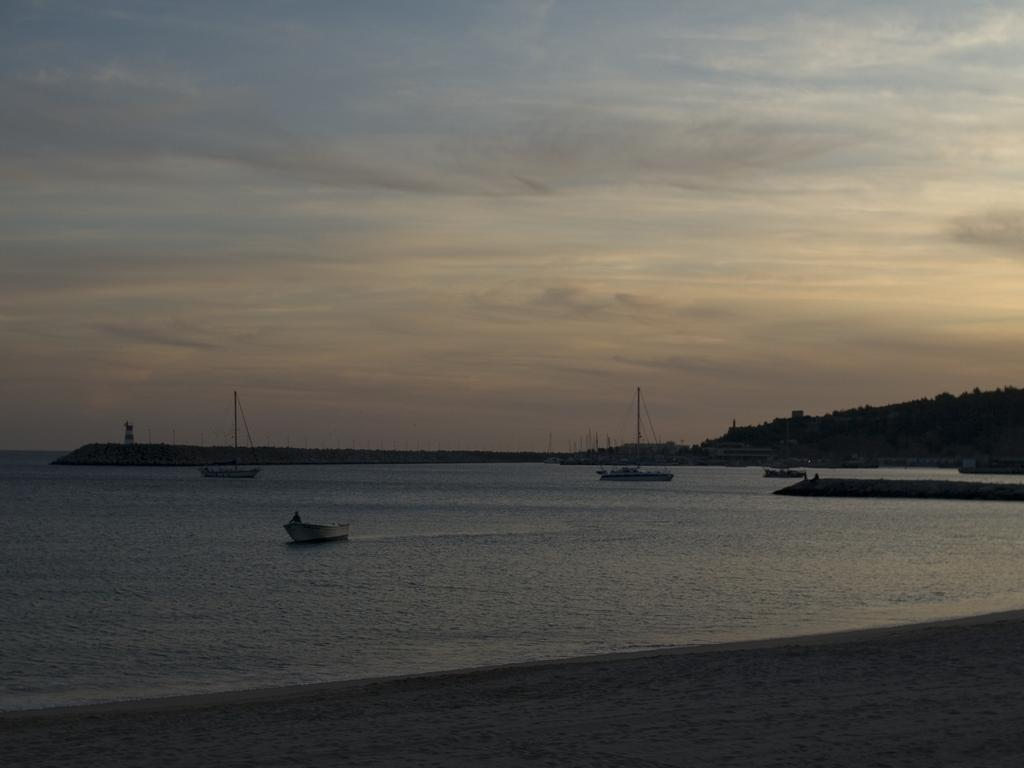What is the main subject of the image? The main subject of the image is boats. Where are the boats located? The boats are on the water. What can be seen in the right corner of the image? There are trees in the right corner of the image. What type of table is visible in the image? There is no table present in the image; it features boats on the water and trees in the right corner. How does the thread appear in the image? There is no thread present in the image. 